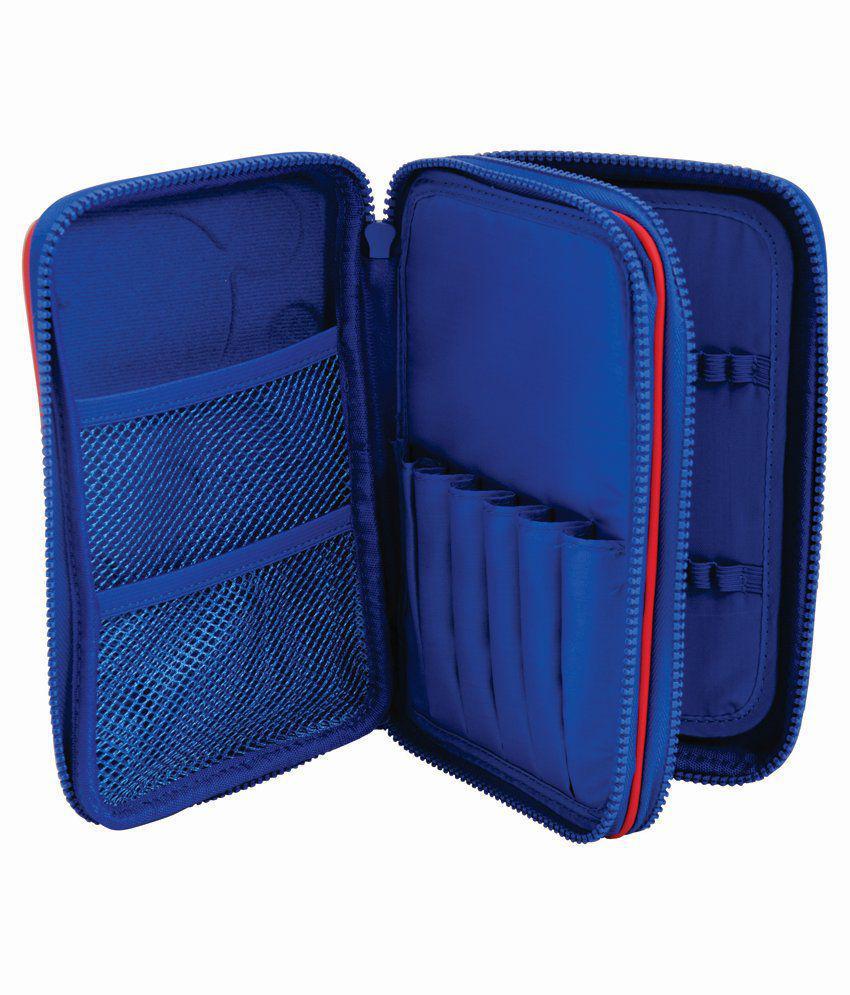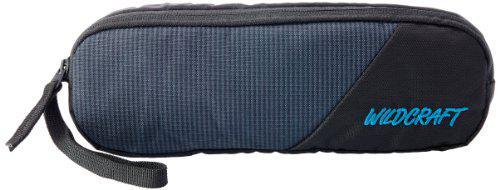The first image is the image on the left, the second image is the image on the right. Evaluate the accuracy of this statement regarding the images: "One case is zipped shut and displayed horizontally, while the other is a blue multi-zippered compartment case displayed upright, open, and fanned out.". Is it true? Answer yes or no. Yes. The first image is the image on the left, the second image is the image on the right. Considering the images on both sides, is "Atleast one item is light blue" valid? Answer yes or no. No. 